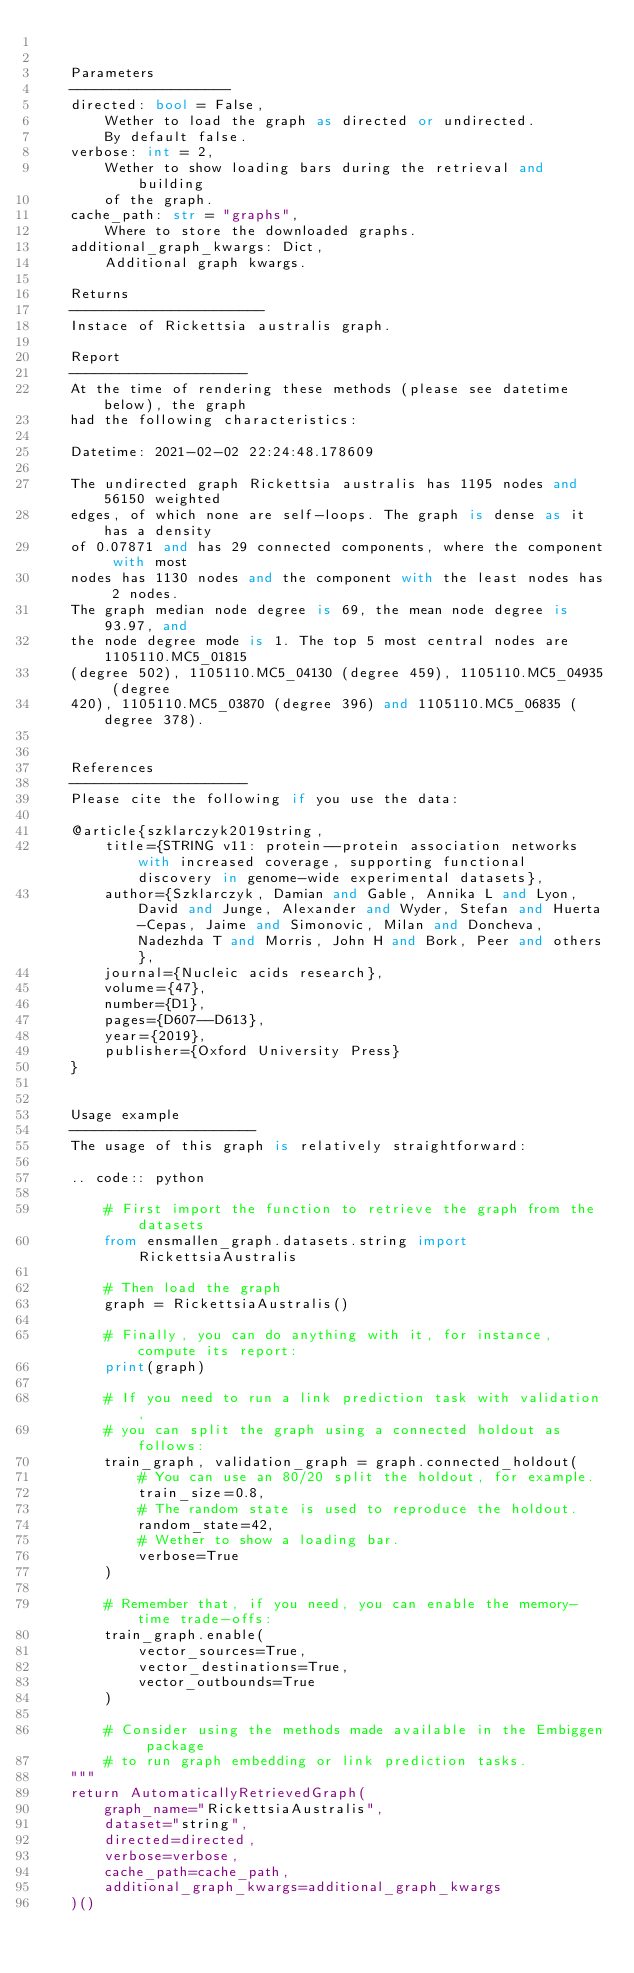<code> <loc_0><loc_0><loc_500><loc_500><_Python_>	

    Parameters
    -------------------
    directed: bool = False,
        Wether to load the graph as directed or undirected.
        By default false.
    verbose: int = 2,
        Wether to show loading bars during the retrieval and building
        of the graph.
    cache_path: str = "graphs",
        Where to store the downloaded graphs.
    additional_graph_kwargs: Dict,
        Additional graph kwargs.

    Returns
    -----------------------
    Instace of Rickettsia australis graph.

	Report
	---------------------
	At the time of rendering these methods (please see datetime below), the graph
	had the following characteristics:
	
	Datetime: 2021-02-02 22:24:48.178609
	
	The undirected graph Rickettsia australis has 1195 nodes and 56150 weighted
	edges, of which none are self-loops. The graph is dense as it has a density
	of 0.07871 and has 29 connected components, where the component with most
	nodes has 1130 nodes and the component with the least nodes has 2 nodes.
	The graph median node degree is 69, the mean node degree is 93.97, and
	the node degree mode is 1. The top 5 most central nodes are 1105110.MC5_01815
	(degree 502), 1105110.MC5_04130 (degree 459), 1105110.MC5_04935 (degree
	420), 1105110.MC5_03870 (degree 396) and 1105110.MC5_06835 (degree 378).
	

	References
	---------------------
	Please cite the following if you use the data:
	
	@article{szklarczyk2019string,
	    title={STRING v11: protein--protein association networks with increased coverage, supporting functional discovery in genome-wide experimental datasets},
	    author={Szklarczyk, Damian and Gable, Annika L and Lyon, David and Junge, Alexander and Wyder, Stefan and Huerta-Cepas, Jaime and Simonovic, Milan and Doncheva, Nadezhda T and Morris, John H and Bork, Peer and others},
	    journal={Nucleic acids research},
	    volume={47},
	    number={D1},
	    pages={D607--D613},
	    year={2019},
	    publisher={Oxford University Press}
	}
	

	Usage example
	----------------------
	The usage of this graph is relatively straightforward:
	
	.. code:: python
	
	    # First import the function to retrieve the graph from the datasets
	    from ensmallen_graph.datasets.string import RickettsiaAustralis
	
	    # Then load the graph
	    graph = RickettsiaAustralis()
	
	    # Finally, you can do anything with it, for instance, compute its report:
	    print(graph)
	
	    # If you need to run a link prediction task with validation,
	    # you can split the graph using a connected holdout as follows:
	    train_graph, validation_graph = graph.connected_holdout(
	        # You can use an 80/20 split the holdout, for example.
	        train_size=0.8,
	        # The random state is used to reproduce the holdout.
	        random_state=42,
	        # Wether to show a loading bar.
	        verbose=True
	    )
	
	    # Remember that, if you need, you can enable the memory-time trade-offs:
	    train_graph.enable(
	        vector_sources=True,
	        vector_destinations=True,
	        vector_outbounds=True
	    )
	
	    # Consider using the methods made available in the Embiggen package
	    # to run graph embedding or link prediction tasks.
    """
    return AutomaticallyRetrievedGraph(
        graph_name="RickettsiaAustralis",
        dataset="string",
        directed=directed,
        verbose=verbose,
        cache_path=cache_path,
        additional_graph_kwargs=additional_graph_kwargs
    )()
</code> 